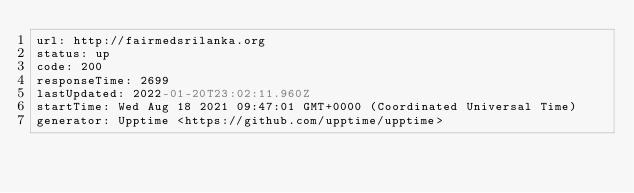Convert code to text. <code><loc_0><loc_0><loc_500><loc_500><_YAML_>url: http://fairmedsrilanka.org
status: up
code: 200
responseTime: 2699
lastUpdated: 2022-01-20T23:02:11.960Z
startTime: Wed Aug 18 2021 09:47:01 GMT+0000 (Coordinated Universal Time)
generator: Upptime <https://github.com/upptime/upptime>
</code> 